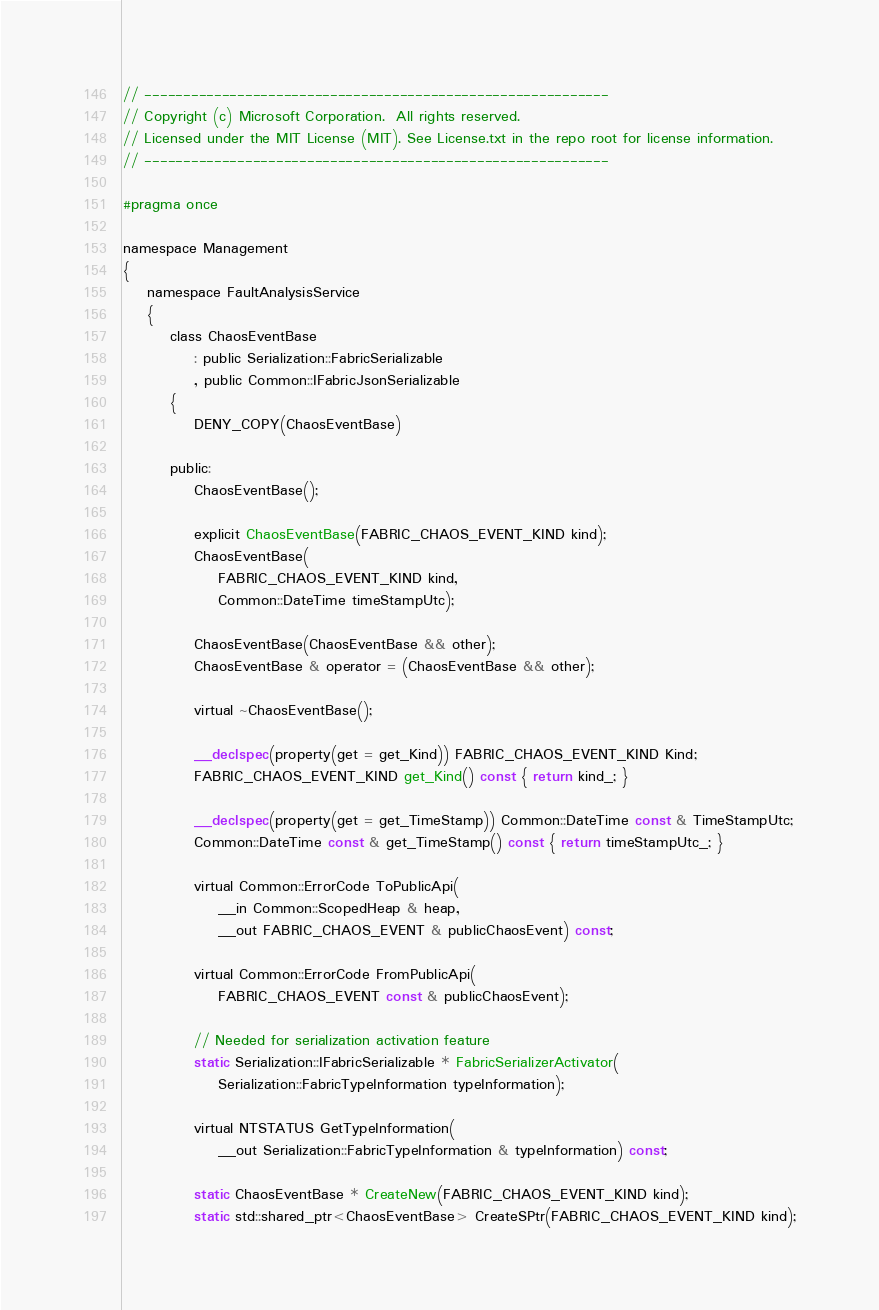Convert code to text. <code><loc_0><loc_0><loc_500><loc_500><_C_>// ------------------------------------------------------------
// Copyright (c) Microsoft Corporation.  All rights reserved.
// Licensed under the MIT License (MIT). See License.txt in the repo root for license information.
// ------------------------------------------------------------

#pragma once

namespace Management
{
    namespace FaultAnalysisService
    {
        class ChaosEventBase
            : public Serialization::FabricSerializable
            , public Common::IFabricJsonSerializable
        {
            DENY_COPY(ChaosEventBase)

        public:
            ChaosEventBase();

            explicit ChaosEventBase(FABRIC_CHAOS_EVENT_KIND kind);
            ChaosEventBase(
                FABRIC_CHAOS_EVENT_KIND kind,
                Common::DateTime timeStampUtc);

            ChaosEventBase(ChaosEventBase && other);
            ChaosEventBase & operator = (ChaosEventBase && other);

            virtual ~ChaosEventBase();

            __declspec(property(get = get_Kind)) FABRIC_CHAOS_EVENT_KIND Kind;
            FABRIC_CHAOS_EVENT_KIND get_Kind() const { return kind_; }

            __declspec(property(get = get_TimeStamp)) Common::DateTime const & TimeStampUtc;
            Common::DateTime const & get_TimeStamp() const { return timeStampUtc_; }

            virtual Common::ErrorCode ToPublicApi(
                __in Common::ScopedHeap & heap,
                __out FABRIC_CHAOS_EVENT & publicChaosEvent) const;

            virtual Common::ErrorCode FromPublicApi(
                FABRIC_CHAOS_EVENT const & publicChaosEvent);

            // Needed for serialization activation feature
            static Serialization::IFabricSerializable * FabricSerializerActivator(
                Serialization::FabricTypeInformation typeInformation);

            virtual NTSTATUS GetTypeInformation(
                __out Serialization::FabricTypeInformation & typeInformation) const;

            static ChaosEventBase * CreateNew(FABRIC_CHAOS_EVENT_KIND kind);
            static std::shared_ptr<ChaosEventBase> CreateSPtr(FABRIC_CHAOS_EVENT_KIND kind);
</code> 